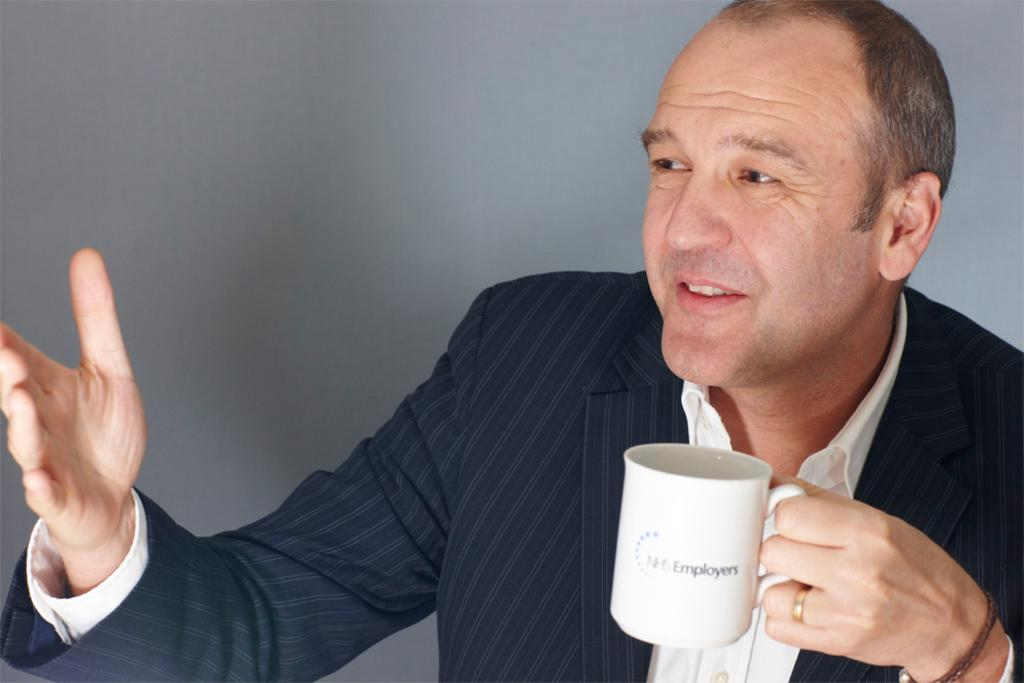What is the main subject of the image? There is a person in the image. What is the person doing in the image? The person is smiling. What object is the person holding in the image? The person is holding a cup. What type of bear can be seen holding a jar in the image? There is no bear or jar present in the image; it features a person holding a cup. 